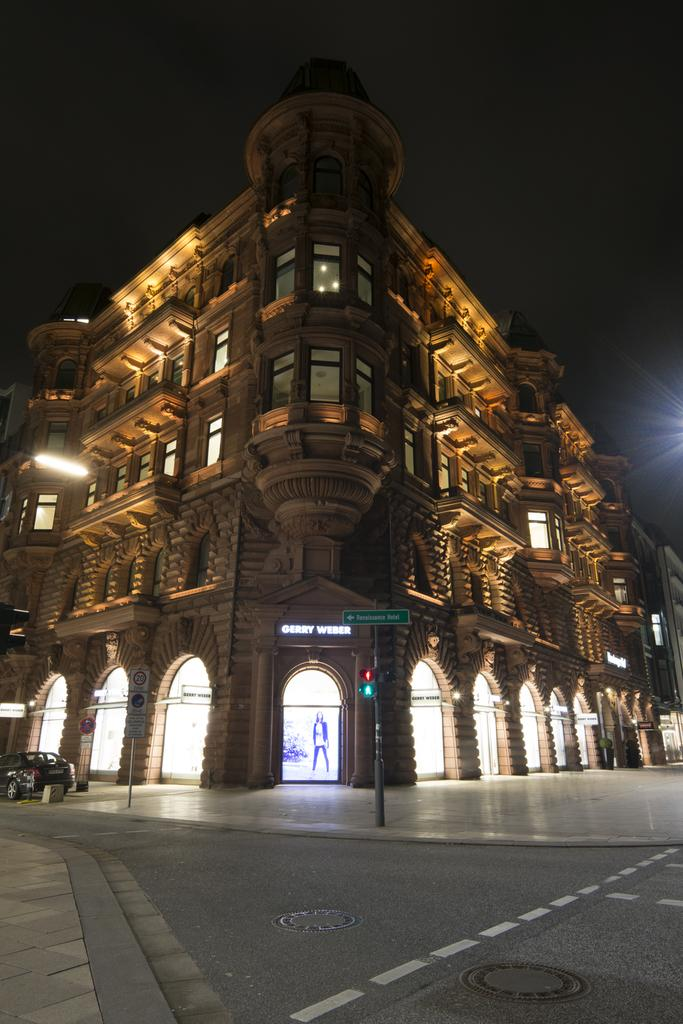What is the main feature of the image? There is a road in the image. What is located near the road? There is a sign board with a pole near the road. What can be seen on the road? There is a vehicle on the road. What type of structure is visible in the image? There is a building with windows and arches in the image. How would you describe the lighting in the image? The background of the image appears to be dark. Is there a volcano visible on the road in the image? No, there is no volcano present in the image. How many people are walking on the road in the image? There is no mention of people walking on the road in the image, so it cannot be determined. 